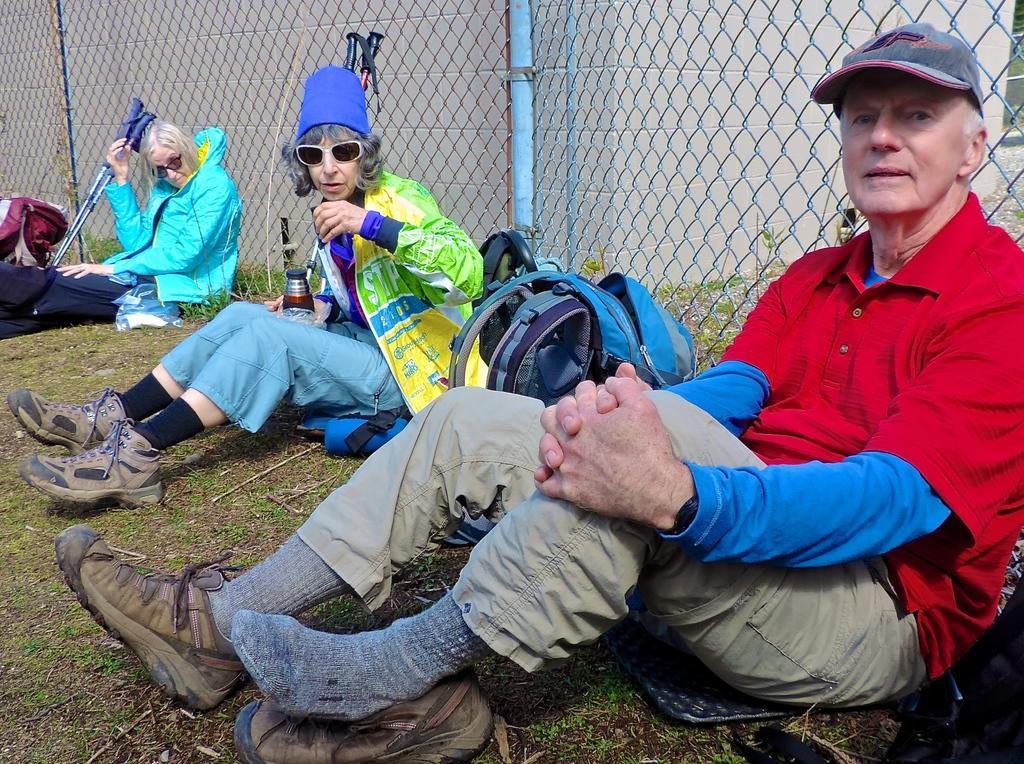Please provide a concise description of this image. In this picture I can observe three members sitting on the land. Behind them I can observe fence. In the background there is a wall. 